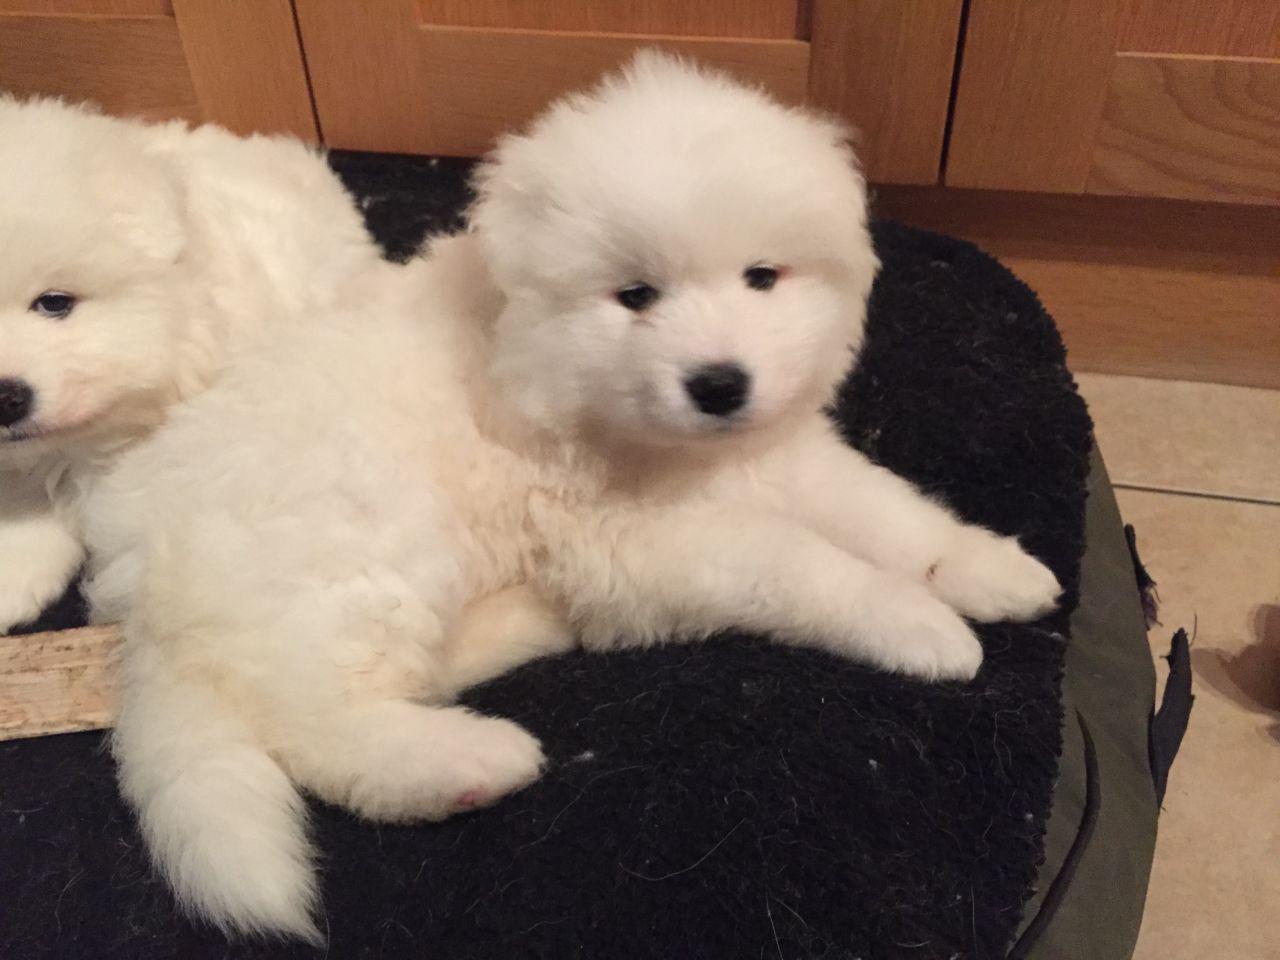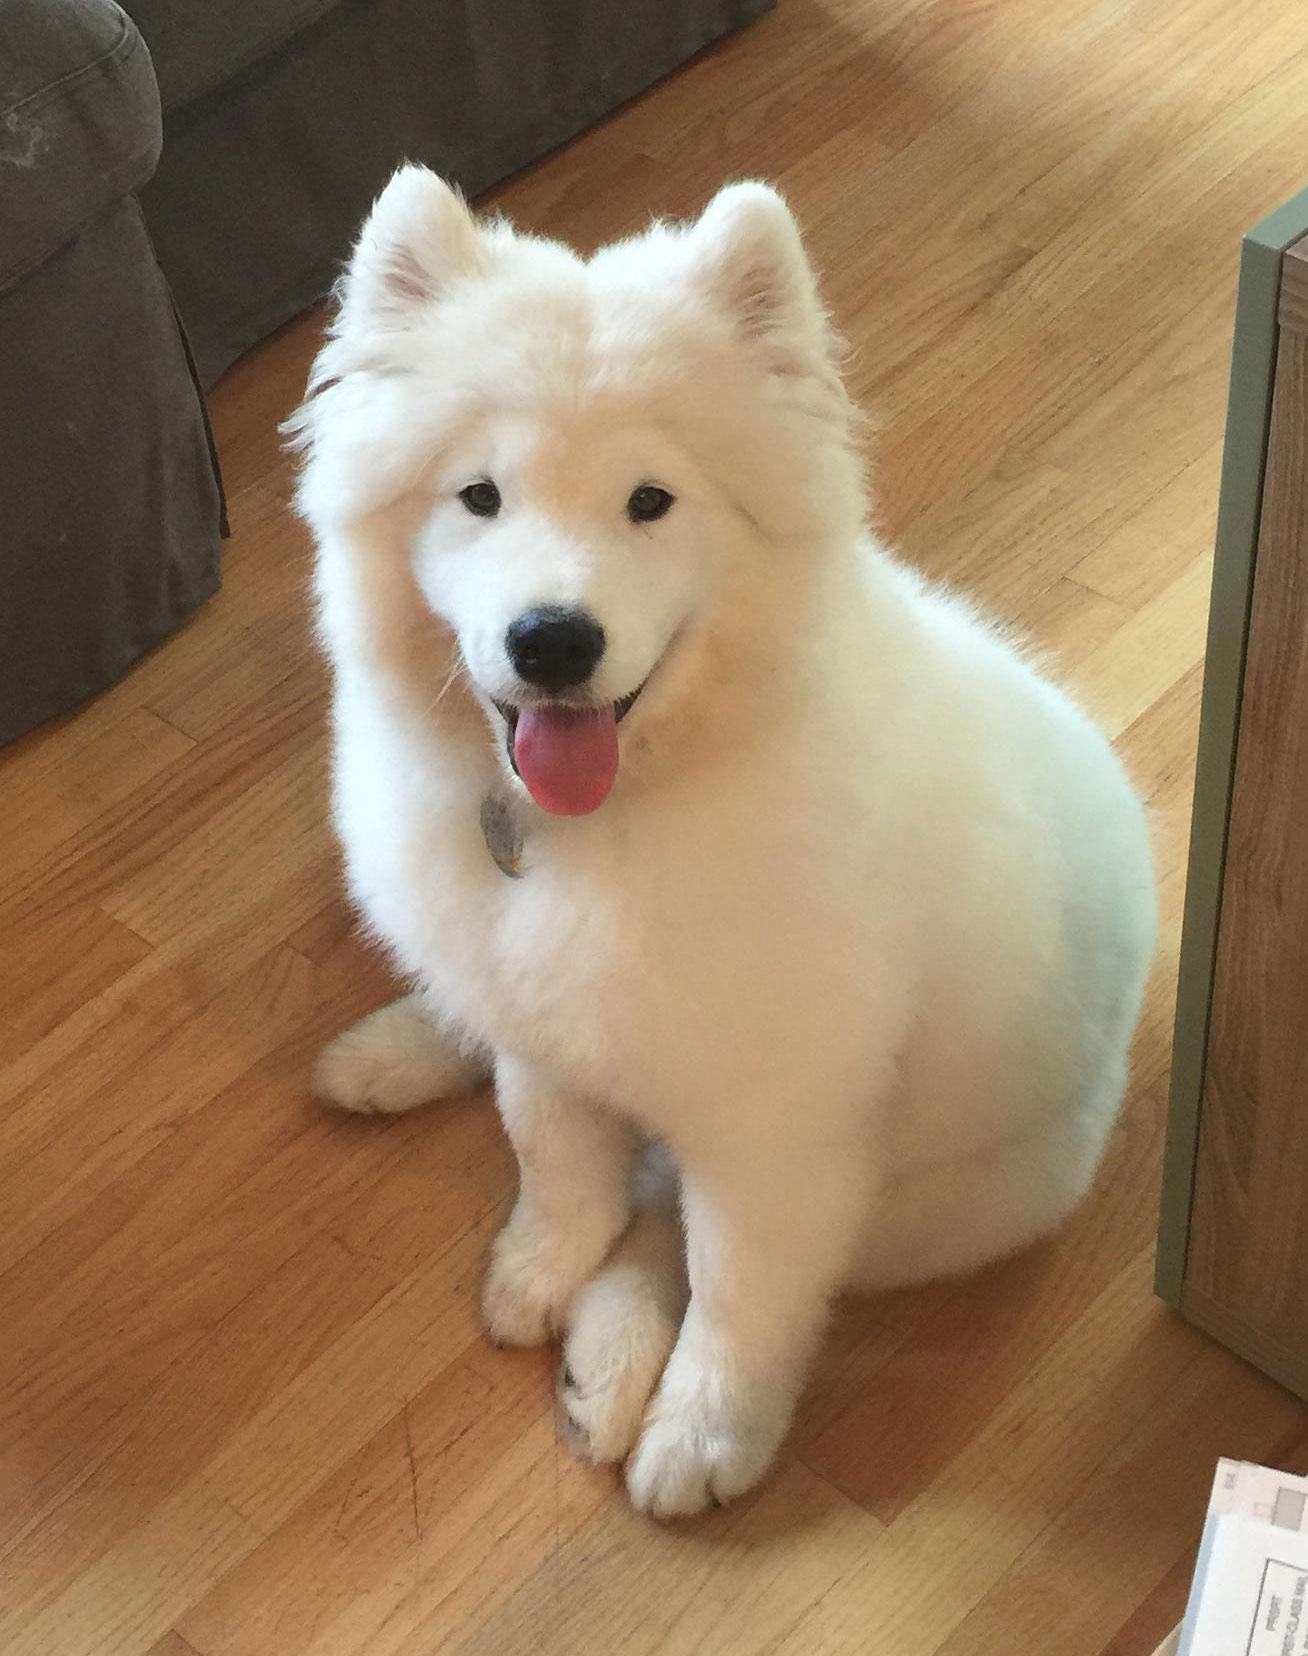The first image is the image on the left, the second image is the image on the right. Assess this claim about the two images: "The dog in the image on the right is on a wooden floor.". Correct or not? Answer yes or no. Yes. The first image is the image on the left, the second image is the image on the right. For the images displayed, is the sentence "Each image contains exactly one reclining white dog." factually correct? Answer yes or no. No. 